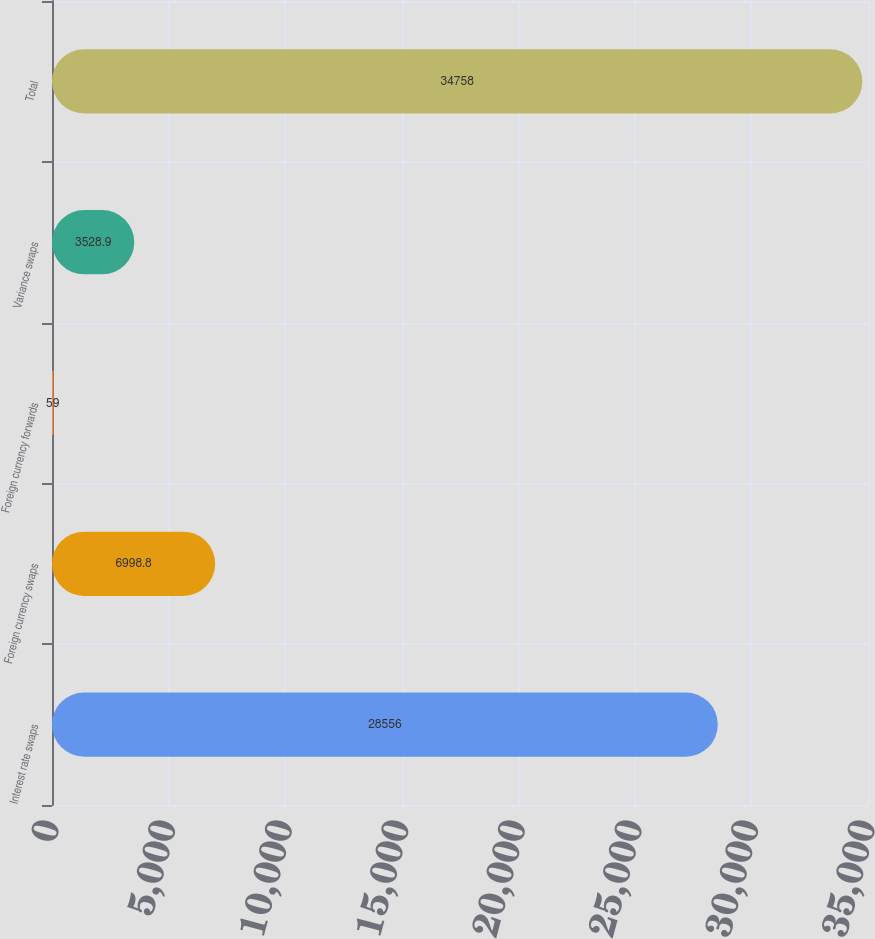<chart> <loc_0><loc_0><loc_500><loc_500><bar_chart><fcel>Interest rate swaps<fcel>Foreign currency swaps<fcel>Foreign currency forwards<fcel>Variance swaps<fcel>Total<nl><fcel>28556<fcel>6998.8<fcel>59<fcel>3528.9<fcel>34758<nl></chart> 